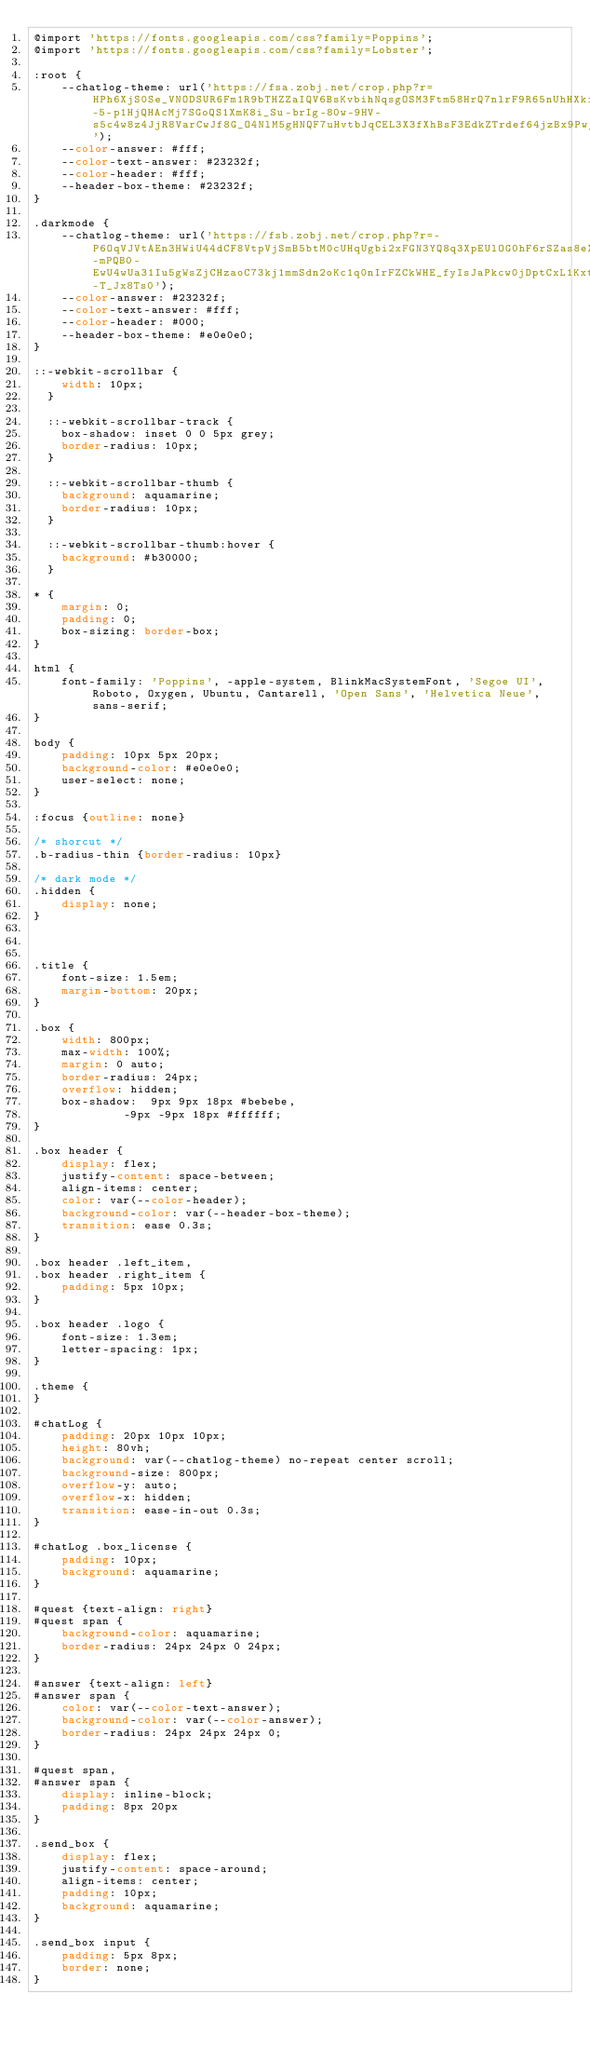Convert code to text. <code><loc_0><loc_0><loc_500><loc_500><_CSS_>@import 'https://fonts.googleapis.com/css?family=Poppins';
@import 'https://fonts.googleapis.com/css?family=Lobster';

:root {
    --chatlog-theme: url('https://fsa.zobj.net/crop.php?r=HPh6XjS0Se_VNODSUR6Fm1R9bTHZZaIQV6BsKvbihNqsgOSM3Ftm58HrQ7nlrF9R65nUhHXkiA34Cu7Y-5-p1HjQHAcMj7SGoQS1XmK8i_Su-brIg-80w-9HV-s5c4w8z4JjR8VarCwJf8G_O4NlM5gHNQF7uHvtbJqCEL3X3fXhBsF3EdkZTrdef64jzBx9PwjBSJ23C_QtWaUi');
    --color-answer: #fff;
    --color-text-answer: #23232f;
    --color-header: #fff;
    --header-box-theme: #23232f;
}

.darkmode {
    --chatlog-theme: url('https://fsb.zobj.net/crop.php?r=-P6OqVJVtAEn3HWiU44dCF8VtpVjSmB5btM0cUHqUgbi2xFGN3YQ8q3XpEUlOG0hF6rSZas8eX_zBoKWmF3IaPifbkt6ToV-mPQB0-EwU4wUa31Iu5gWsZjCHzaoC73kj1mmSdn2oKc1q0nIrFZCkWHE_fyIsJaPkcw0jDptCxL1Kxt0me-T_Jx8Ts0');
    --color-answer: #23232f;
    --color-text-answer: #fff;
    --color-header: #000;
    --header-box-theme: #e0e0e0;
}

::-webkit-scrollbar {
    width: 10px;
  }
  
  ::-webkit-scrollbar-track {
    box-shadow: inset 0 0 5px grey; 
    border-radius: 10px;
  }

  ::-webkit-scrollbar-thumb {
    background: aquamarine;
    border-radius: 10px;
  }
  
  ::-webkit-scrollbar-thumb:hover {
    background: #b30000; 
  }

* {
    margin: 0;
    padding: 0;
    box-sizing: border-box;
}

html {
    font-family: 'Poppins', -apple-system, BlinkMacSystemFont, 'Segoe UI', Roboto, Oxygen, Ubuntu, Cantarell, 'Open Sans', 'Helvetica Neue', sans-serif;
}

body {
    padding: 10px 5px 20px;
    background-color: #e0e0e0;
    user-select: none;
}

:focus {outline: none}

/* shorcut */
.b-radius-thin {border-radius: 10px}

/* dark mode */
.hidden {
    display: none;
}



.title {
    font-size: 1.5em;
    margin-bottom: 20px;
}

.box {
    width: 800px;
    max-width: 100%;
    margin: 0 auto;
    border-radius: 24px;
    overflow: hidden;
    box-shadow:  9px 9px 18px #bebebe,
             -9px -9px 18px #ffffff;
}

.box header {
    display: flex;
    justify-content: space-between;
    align-items: center;
    color: var(--color-header);
    background-color: var(--header-box-theme);
    transition: ease 0.3s;
}

.box header .left_item,
.box header .right_item {
    padding: 5px 10px;
}

.box header .logo {
    font-size: 1.3em;
    letter-spacing: 1px;
}

.theme {
}

#chatLog {
    padding: 20px 10px 10px;
    height: 80vh;
    background: var(--chatlog-theme) no-repeat center scroll;
    background-size: 800px;
    overflow-y: auto;
    overflow-x: hidden;
    transition: ease-in-out 0.3s;
}

#chatLog .box_license {
    padding: 10px;
    background: aquamarine;
}

#quest {text-align: right}
#quest span {
    background-color: aquamarine;
    border-radius: 24px 24px 0 24px;
}

#answer {text-align: left}
#answer span {
    color: var(--color-text-answer);
    background-color: var(--color-answer);
    border-radius: 24px 24px 24px 0;
}

#quest span,
#answer span {
    display: inline-block;
    padding: 8px 20px
}

.send_box {
    display: flex;
    justify-content: space-around;
    align-items: center;
    padding: 10px;
    background: aquamarine;
}

.send_box input {
    padding: 5px 8px;
    border: none;
}

</code> 